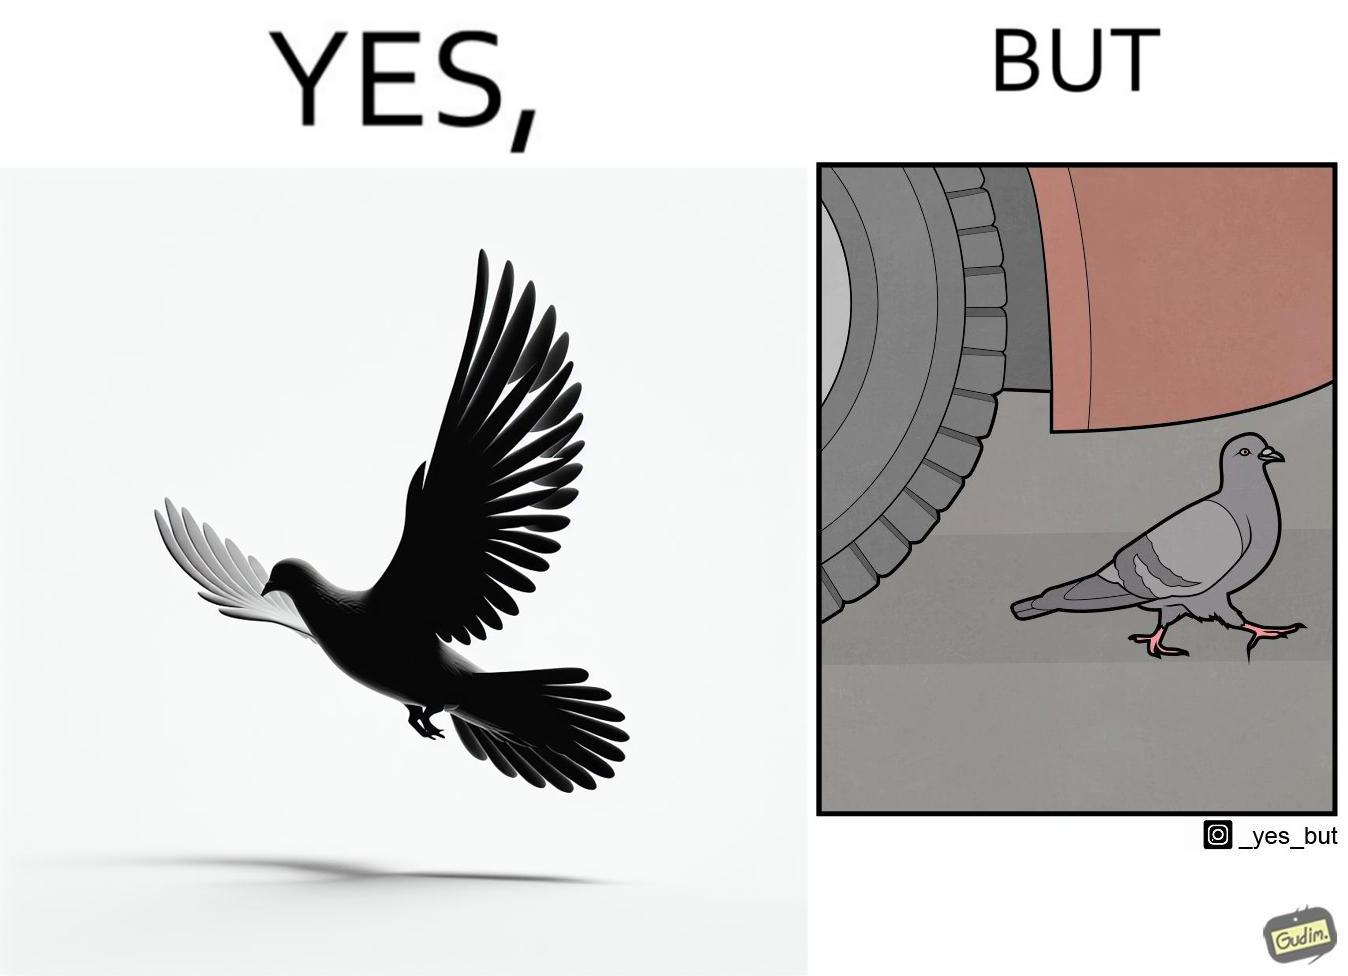Describe what you see in this image. The image is ironic, because even when the pigeon has wings to fly it is walking even when it seems threatening to its life 